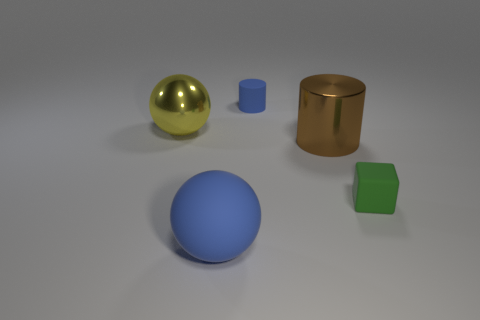How many green objects are large metallic things or small metallic spheres? In the image, there is one green object which is a small cube and doesn't fit the criteria of a large metallic thing or a small metallic sphere. There are no green objects that are either large metallic things or small metallic spheres, so the answer is 0. 